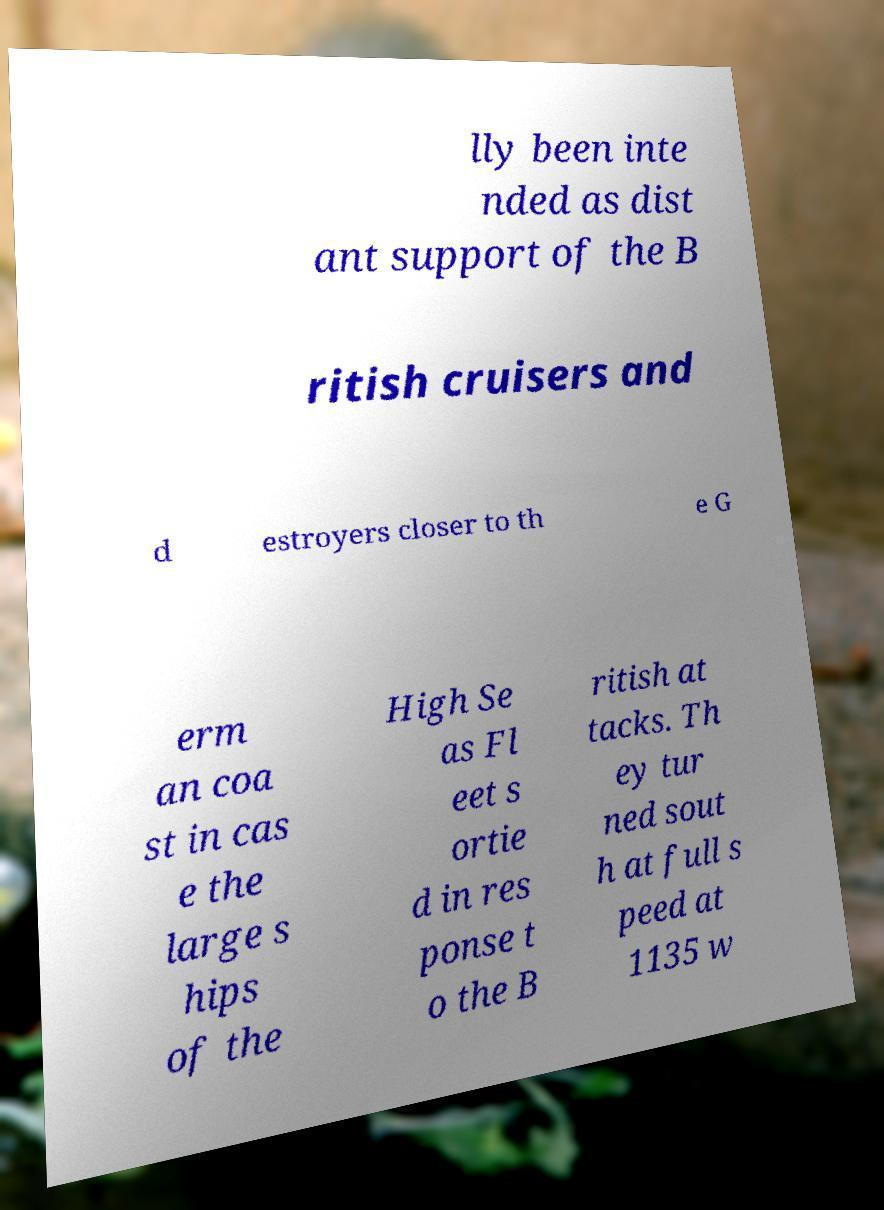Could you extract and type out the text from this image? lly been inte nded as dist ant support of the B ritish cruisers and d estroyers closer to th e G erm an coa st in cas e the large s hips of the High Se as Fl eet s ortie d in res ponse t o the B ritish at tacks. Th ey tur ned sout h at full s peed at 1135 w 